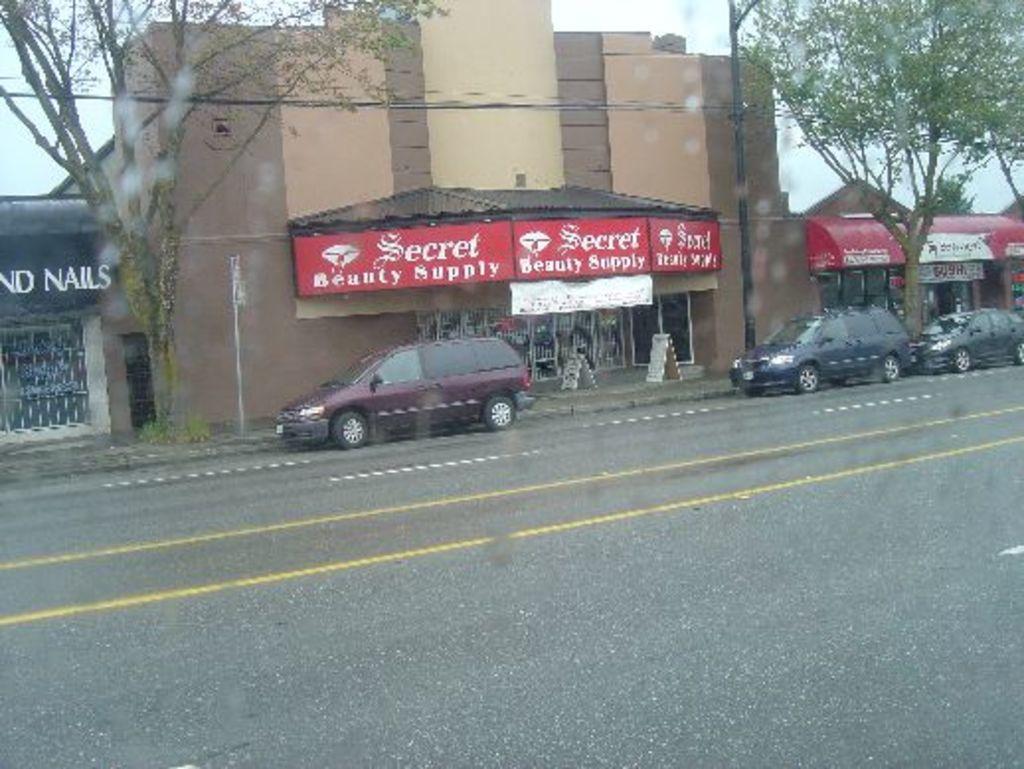How would you summarize this image in a sentence or two? In the given image i can see a stores with some text,cars,trees,road and in the background i can see the sky. 